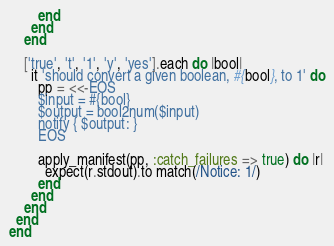<code> <loc_0><loc_0><loc_500><loc_500><_Ruby_>        end
      end
    end

    ['true', 't', '1', 'y', 'yes'].each do |bool|
      it 'should convert a given boolean, #{bool}, to 1' do
        pp = <<-EOS
        $input = #{bool}
        $output = bool2num($input)
        notify { $output: }
        EOS

        apply_manifest(pp, :catch_failures => true) do |r|
          expect(r.stdout).to match(/Notice: 1/)
        end
      end
    end
  end
end
</code> 